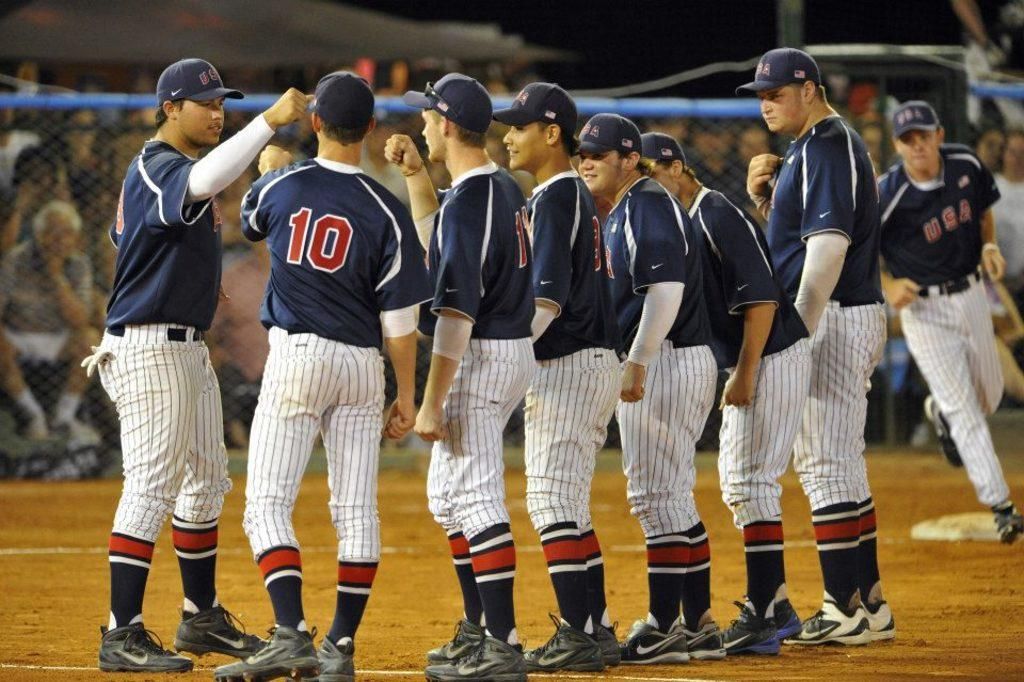<image>
Give a short and clear explanation of the subsequent image. A baseball team wears blue and red uniforms with their numbers and the acronym USA on them. 